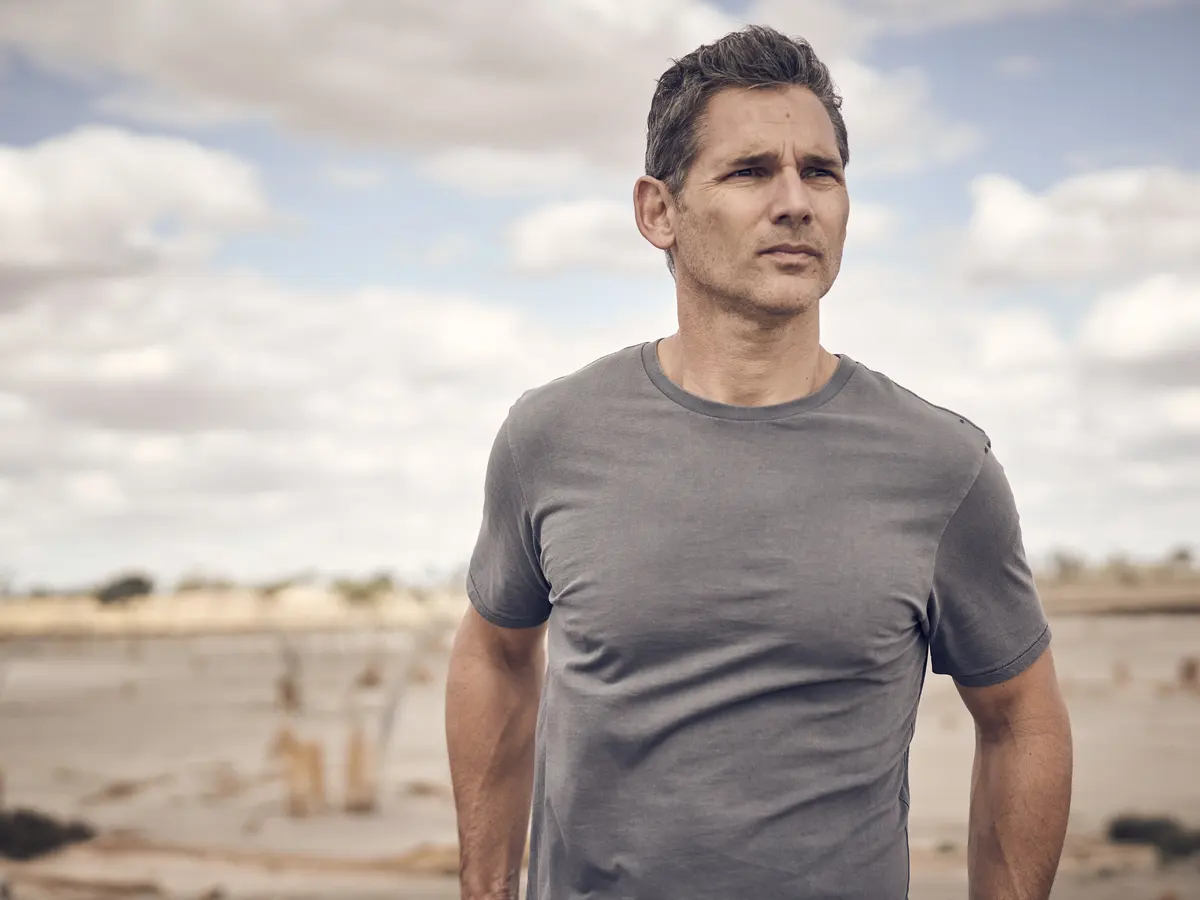Write a detailed description of the given image. In this image, a man is standing on a sandy beach, gazing into the distance with a contemplative expression. He is dressed casually in a gray t-shirt. The background features a beach under an overcast sky, which creates a somber and introspective atmosphere. The clouds in the sky are scattered, adding texture to the scene. The man’s serious demeanor and the tranquil beach setting combine to convey a sense of solitude and reflection. 